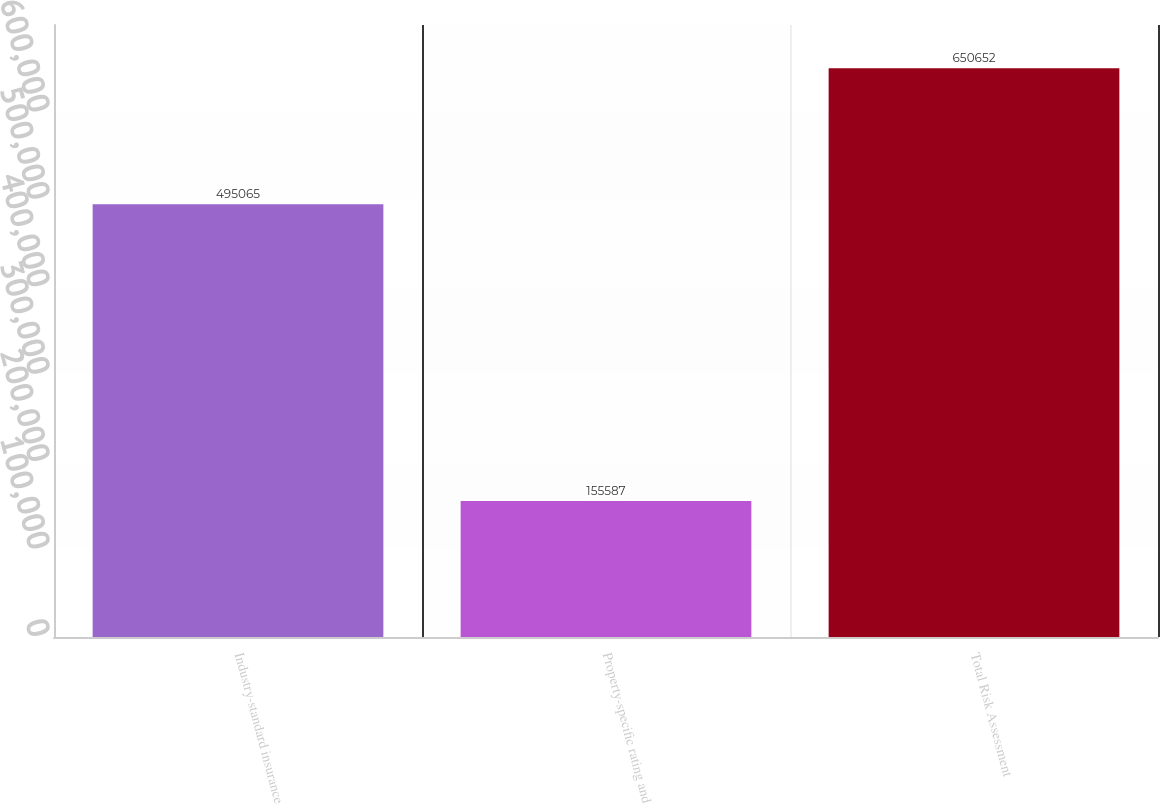<chart> <loc_0><loc_0><loc_500><loc_500><bar_chart><fcel>Industry-standard insurance<fcel>Property-specific rating and<fcel>Total Risk Assessment<nl><fcel>495065<fcel>155587<fcel>650652<nl></chart> 